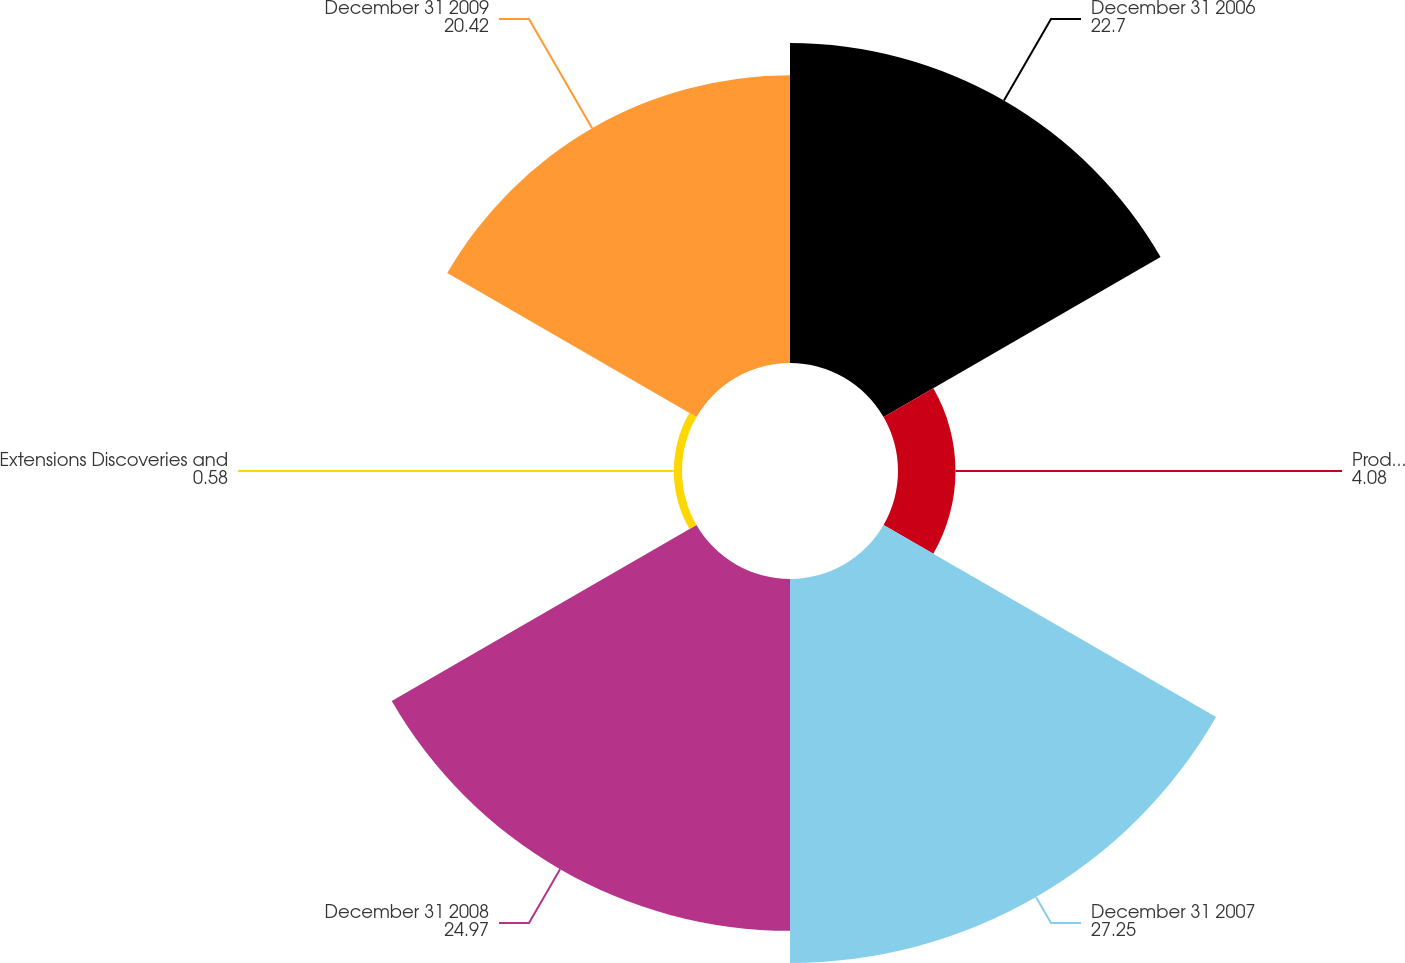Convert chart. <chart><loc_0><loc_0><loc_500><loc_500><pie_chart><fcel>December 31 2006<fcel>Production (4)<fcel>December 31 2007<fcel>December 31 2008<fcel>Extensions Discoveries and<fcel>December 31 2009<nl><fcel>22.7%<fcel>4.08%<fcel>27.25%<fcel>24.97%<fcel>0.58%<fcel>20.42%<nl></chart> 